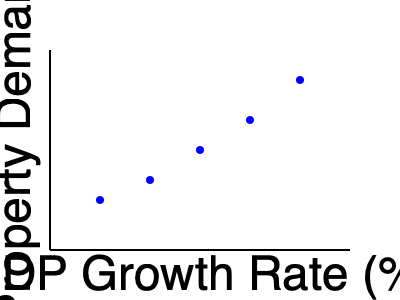Based on the scatter plot showing the relationship between GDP growth rate and luxury property demand index, what can be inferred about the potential impact of a 1% increase in GDP growth rate on luxury property demand? To answer this question, we need to analyze the scatter plot and understand the relationship between GDP growth rate and luxury property demand index:

1. Observe the overall trend: As we move from left to right (increasing GDP growth rate), the points generally move upwards (increasing luxury property demand index).

2. Identify the correlation: The plot shows a positive correlation between GDP growth rate and luxury property demand index.

3. Estimate the slope: Although we don't have exact values, we can roughly estimate the change in luxury property demand index for each 1% increase in GDP growth rate.

4. Calculate the average change: 
   - The x-axis spans approximately 4% GDP growth (from 1% to 5%).
   - The y-axis spans approximately 100 points (from 50 to 150).
   - The total change in demand index is about 100 points over 4% GDP growth.

5. Estimate the impact: On average, a 1% increase in GDP growth rate corresponds to about a 25-point increase in the luxury property demand index (100 points / 4% = 25 points per 1%).

6. Interpret the result: A 1% increase in GDP growth rate is likely to result in a significant increase in luxury property demand, approximately 25 points on the demand index scale.
Answer: Approximately 25-point increase in luxury property demand index 